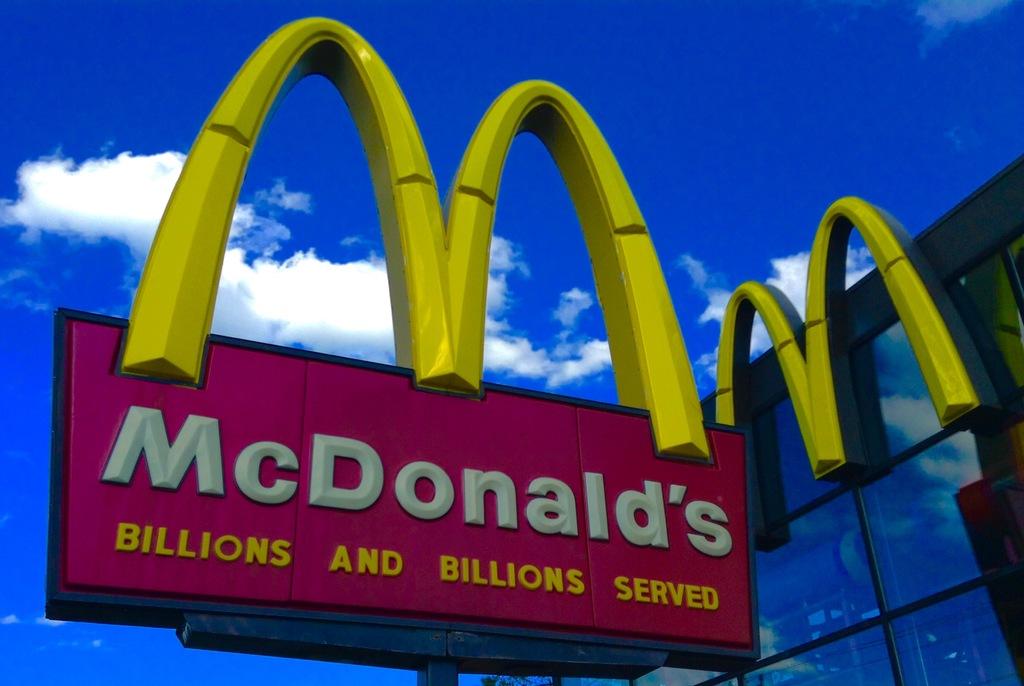Whats the restaurant?
Offer a terse response. Mcdonalds. 